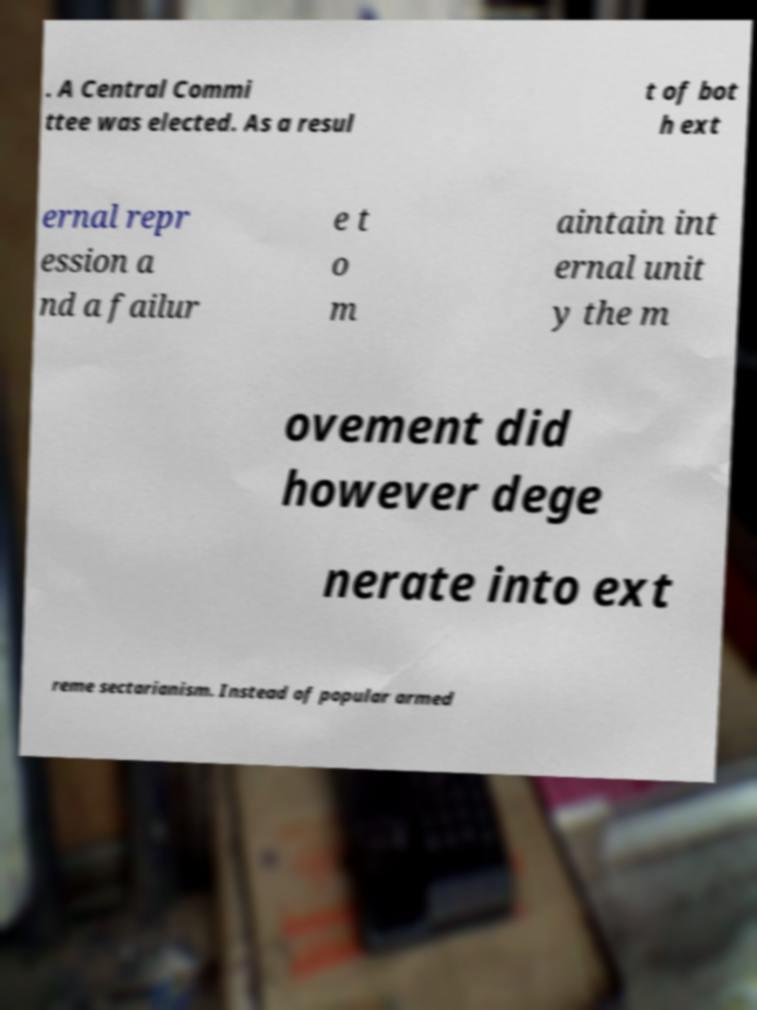I need the written content from this picture converted into text. Can you do that? . A Central Commi ttee was elected. As a resul t of bot h ext ernal repr ession a nd a failur e t o m aintain int ernal unit y the m ovement did however dege nerate into ext reme sectarianism. Instead of popular armed 